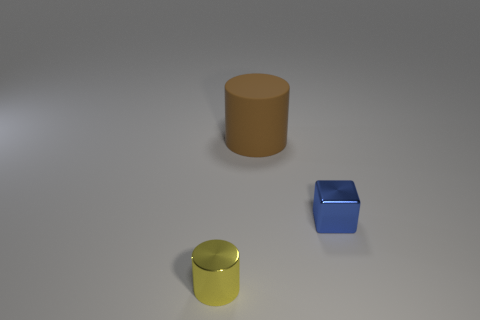Add 3 cubes. How many objects exist? 6 Subtract all cylinders. How many objects are left? 1 Subtract 0 red blocks. How many objects are left? 3 Subtract all small yellow rubber spheres. Subtract all big brown matte objects. How many objects are left? 2 Add 3 tiny metallic blocks. How many tiny metallic blocks are left? 4 Add 3 small blue cylinders. How many small blue cylinders exist? 3 